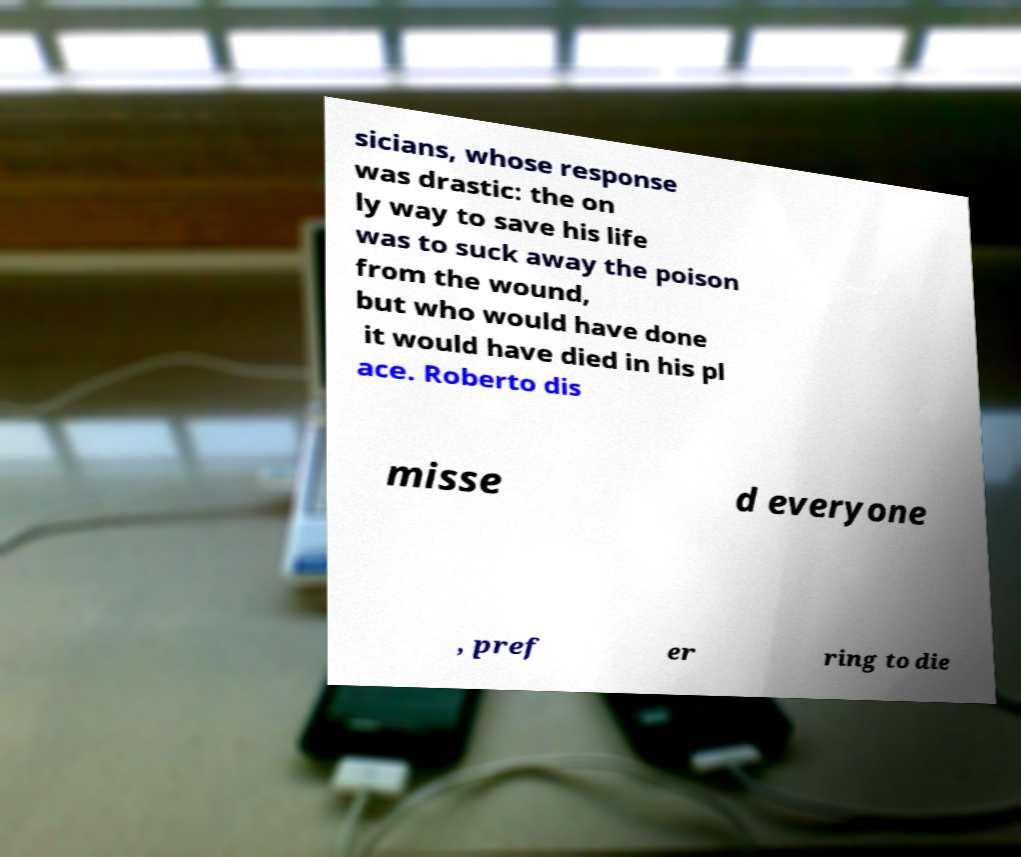Can you read and provide the text displayed in the image?This photo seems to have some interesting text. Can you extract and type it out for me? sicians, whose response was drastic: the on ly way to save his life was to suck away the poison from the wound, but who would have done it would have died in his pl ace. Roberto dis misse d everyone , pref er ring to die 